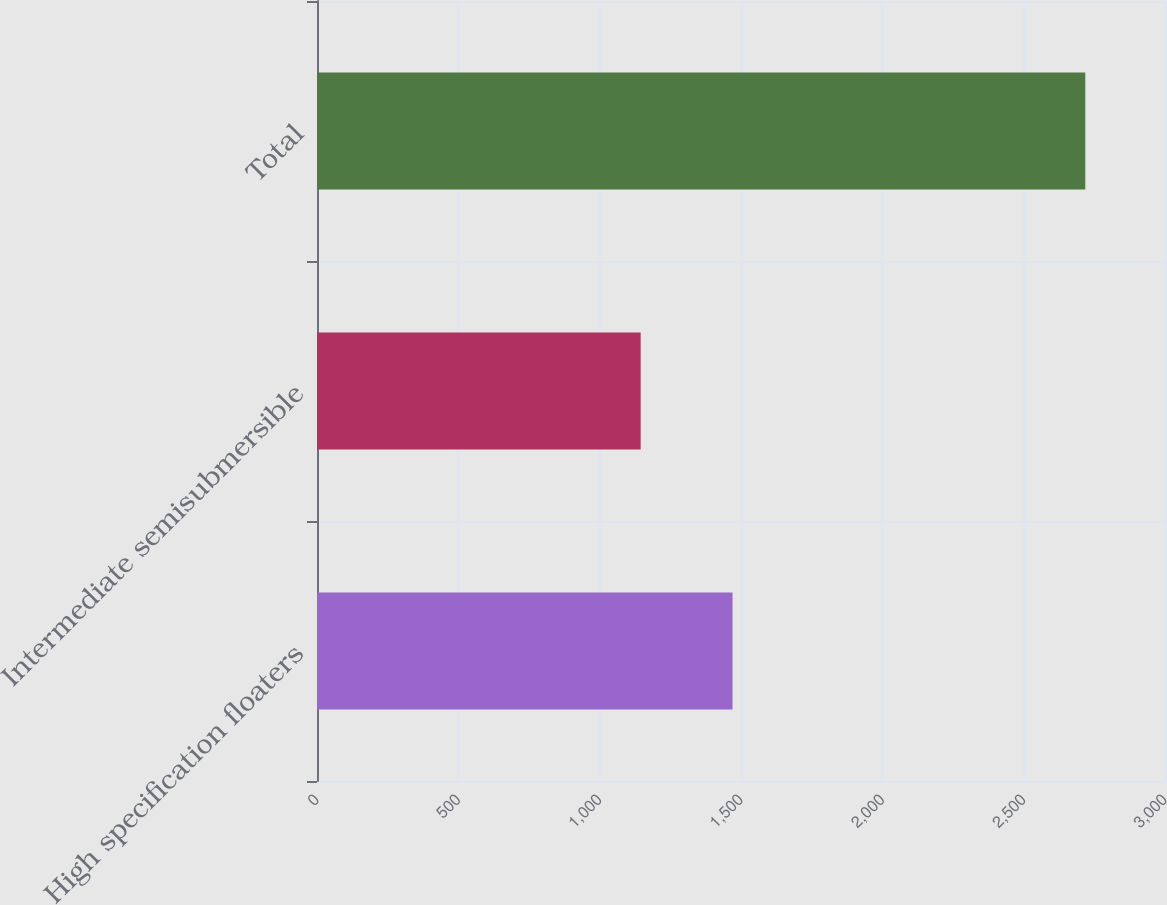Convert chart to OTSL. <chart><loc_0><loc_0><loc_500><loc_500><bar_chart><fcel>High specification floaters<fcel>Intermediate semisubmersible<fcel>Total<nl><fcel>1470<fcel>1145<fcel>2718<nl></chart> 